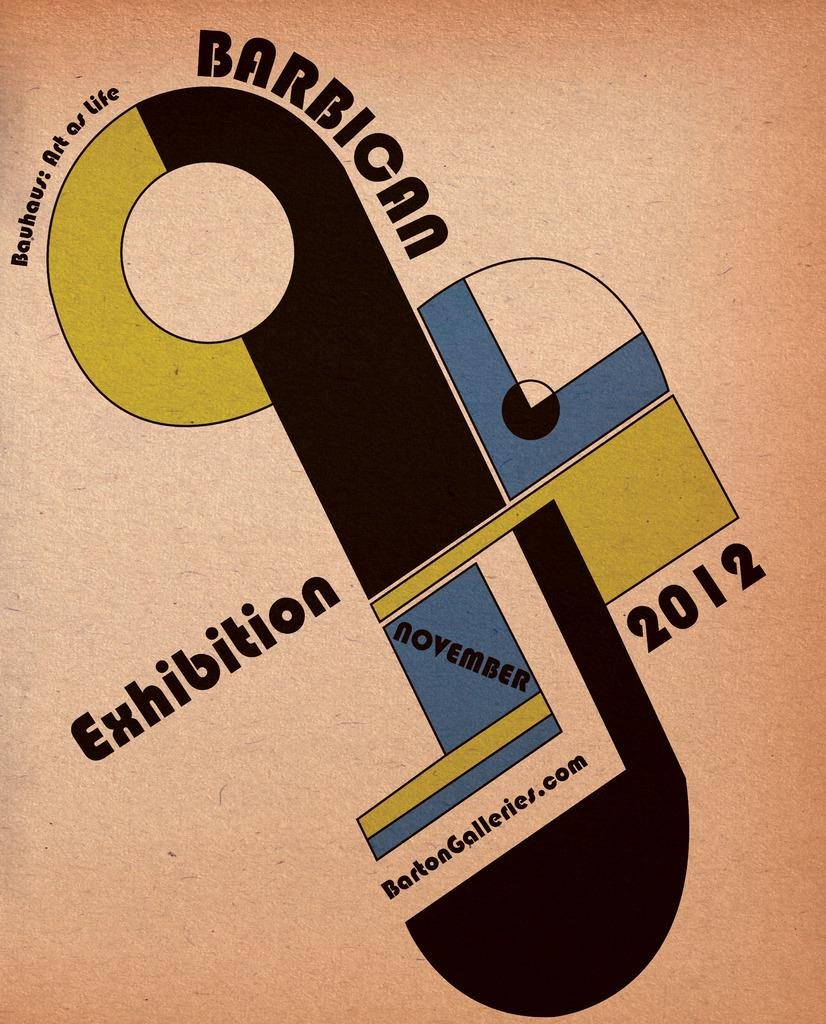Provide a one-sentence caption for the provided image. A pocter for the Barbican Exhibition that was held November 2012. 